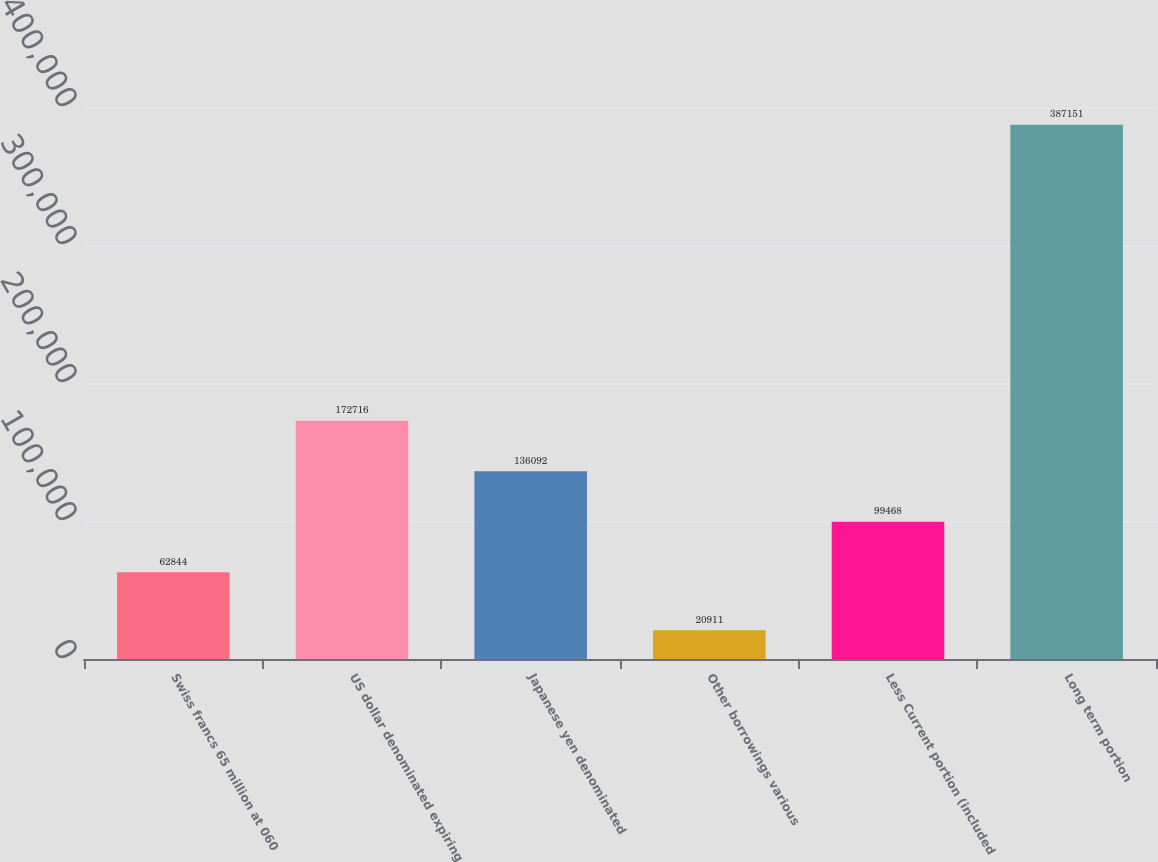Convert chart to OTSL. <chart><loc_0><loc_0><loc_500><loc_500><bar_chart><fcel>Swiss francs 65 million at 060<fcel>US dollar denominated expiring<fcel>Japanese yen denominated<fcel>Other borrowings various<fcel>Less Current portion (included<fcel>Long term portion<nl><fcel>62844<fcel>172716<fcel>136092<fcel>20911<fcel>99468<fcel>387151<nl></chart> 